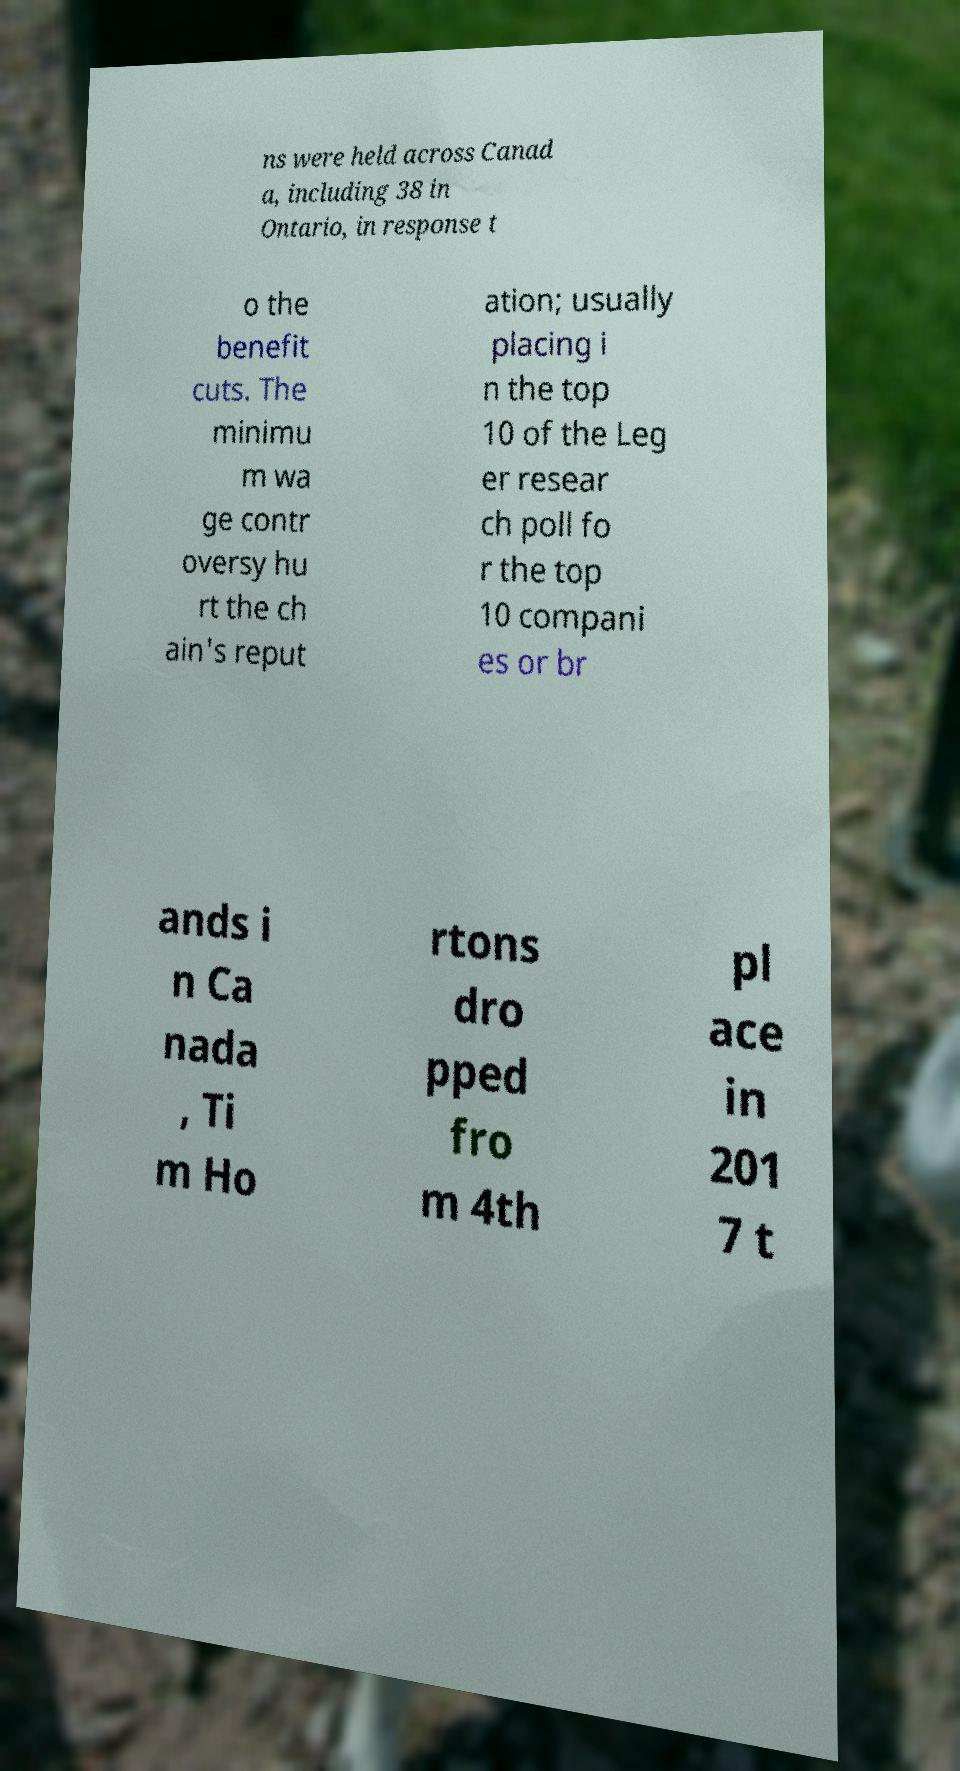Can you read and provide the text displayed in the image?This photo seems to have some interesting text. Can you extract and type it out for me? ns were held across Canad a, including 38 in Ontario, in response t o the benefit cuts. The minimu m wa ge contr oversy hu rt the ch ain's reput ation; usually placing i n the top 10 of the Leg er resear ch poll fo r the top 10 compani es or br ands i n Ca nada , Ti m Ho rtons dro pped fro m 4th pl ace in 201 7 t 